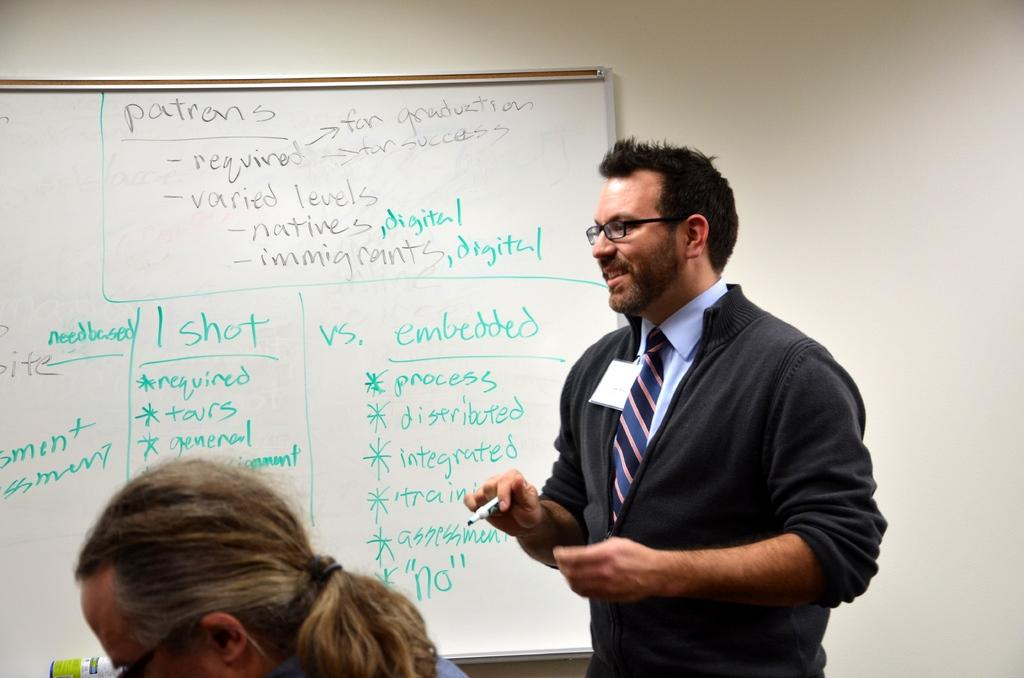What is the person in the image wearing on their face? The person is wearing specs in the image. What is the person holding in their hand? The person is holding a pen in the image. How many people are present in the image? There are two people in the image. What can be seen on the wall in the background? There is a board on the wall in the background. What is written or displayed on the board? Something is written on the board. What type of toys can be seen on the stage in the image? There is no stage or toys present in the image. 